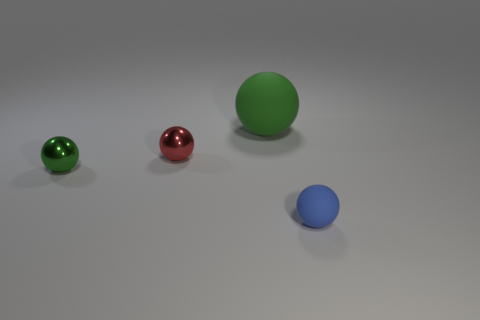Subtract all red balls. How many balls are left? 3 Subtract all red balls. How many balls are left? 3 Add 1 big matte cubes. How many objects exist? 5 Subtract 2 green spheres. How many objects are left? 2 Subtract 2 spheres. How many spheres are left? 2 Subtract all blue balls. Subtract all red cylinders. How many balls are left? 3 Subtract all red blocks. How many green spheres are left? 2 Subtract all big brown cylinders. Subtract all red balls. How many objects are left? 3 Add 4 tiny blue balls. How many tiny blue balls are left? 5 Add 4 metallic spheres. How many metallic spheres exist? 6 